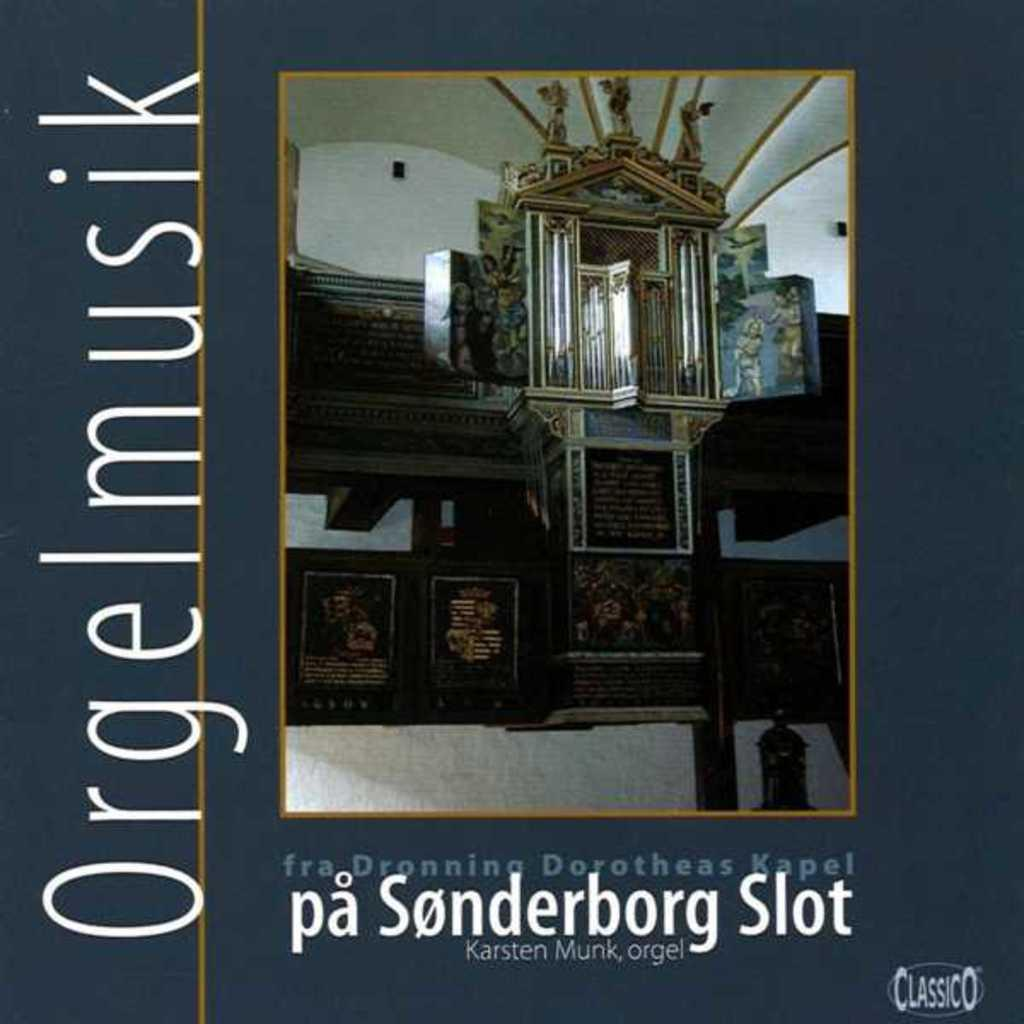What type of visual representation is shown in the image? The image is a poster. What subjects are depicted on the poster? There are boards, paintings, and small sculptures visible on the poster. Are there any noticeable marks or features on the poster? Yes, there are watermarks on the image. What type of machine is shown working with the sculptures in the image? There is no machine present in the image; it only features boards, paintings, and small sculptures. Can you tell me how many teeth the friend in the image has? There is no person or friend depicted in the image, so it is not possible to determine the number of teeth. 